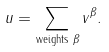<formula> <loc_0><loc_0><loc_500><loc_500>u = \sum _ { \text {weights } \beta } v ^ { \beta } .</formula> 